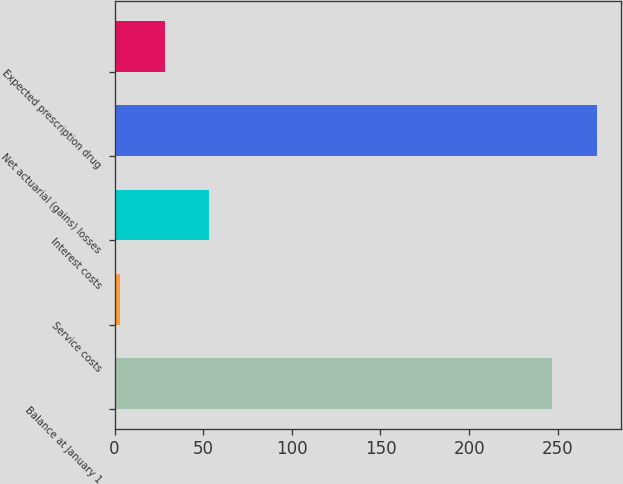Convert chart to OTSL. <chart><loc_0><loc_0><loc_500><loc_500><bar_chart><fcel>Balance at January 1<fcel>Service costs<fcel>Interest costs<fcel>Net actuarial (gains) losses<fcel>Expected prescription drug<nl><fcel>247<fcel>3<fcel>53.4<fcel>272.2<fcel>28.2<nl></chart> 